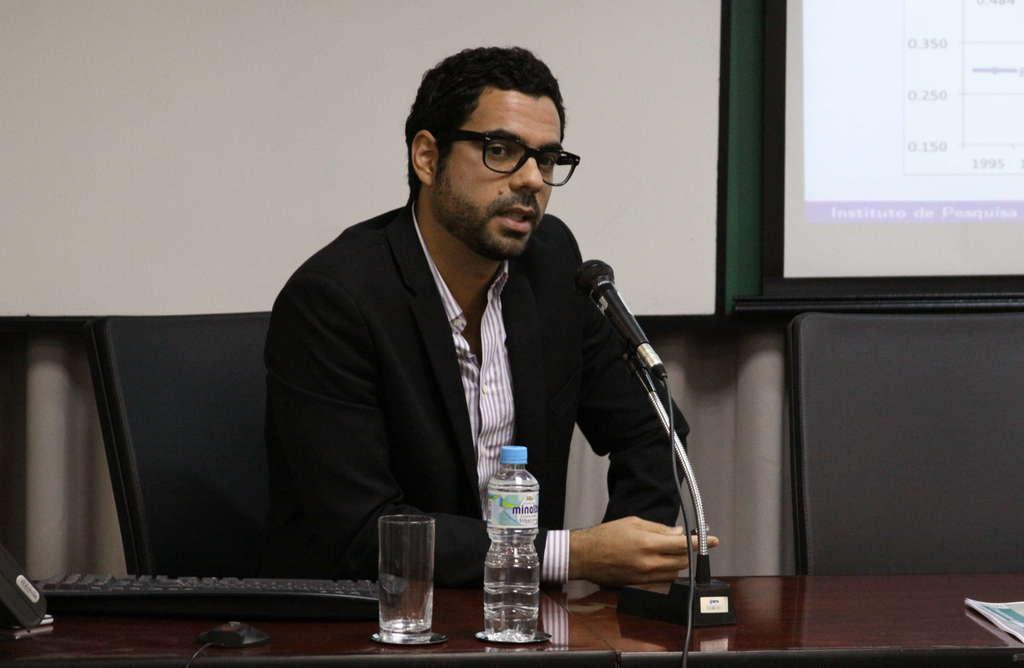What is the man in the image doing? The man is sitting on a chair in the image. What object is in front of the man? There is a keyboard, a glass, a bottle, and a mic in front of the man. What can be seen in the background of the image? There is a screen visible in the background of the image. What type of nail is the man using to taste the north in the image? There is no nail, taste, or north present in the image. 